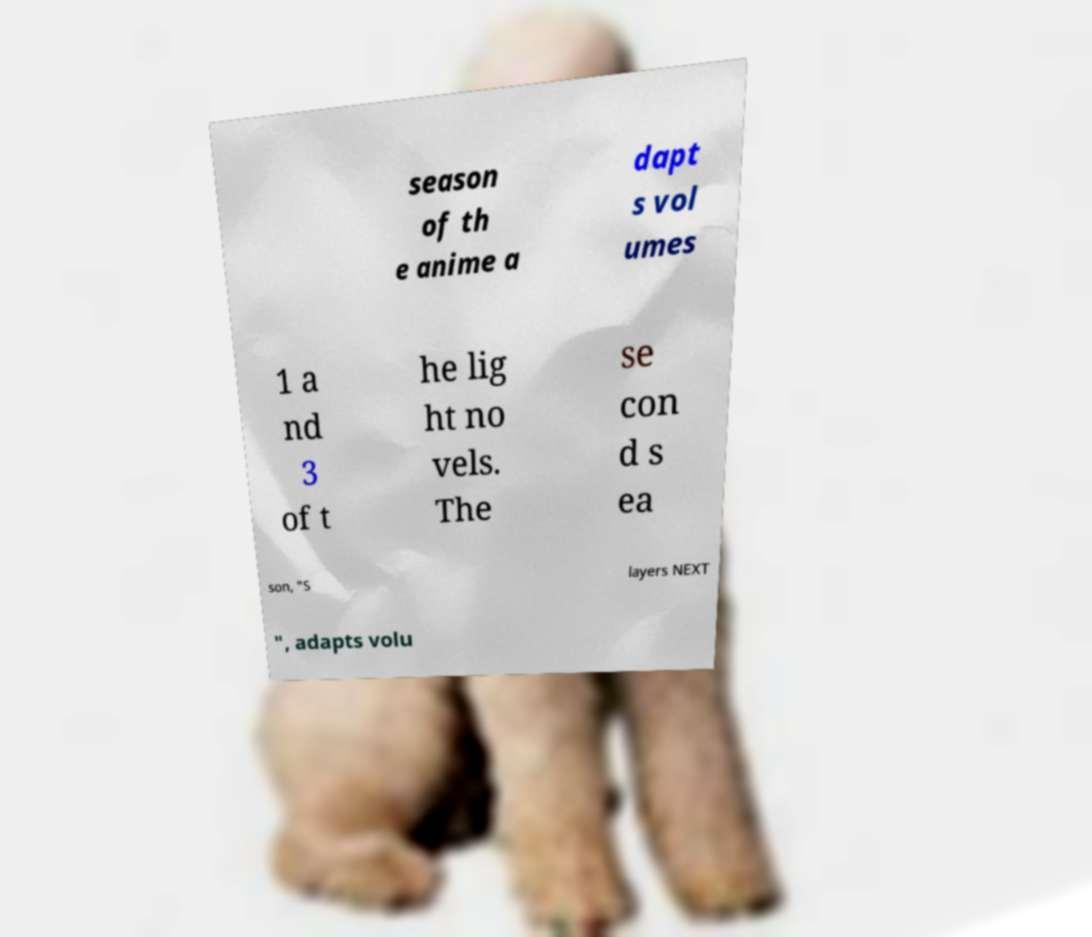Can you accurately transcribe the text from the provided image for me? season of th e anime a dapt s vol umes 1 a nd 3 of t he lig ht no vels. The se con d s ea son, "S layers NEXT ", adapts volu 